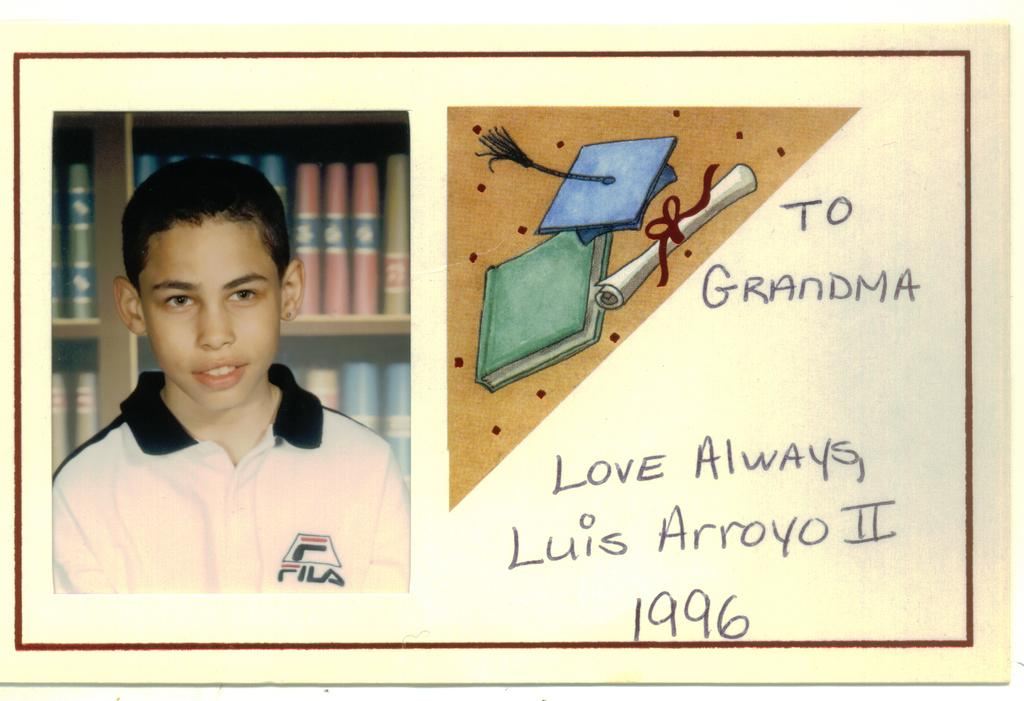What is featured in the image? There is a poster in the image. What can be seen on the poster? The poster contains an image of a kid. How is the kid depicted in the poster? The kid is smiling. What is visible behind the kid in the poster? There are bookshelves behind the kid in the poster. What type of leather material is visible on the kid's shoes in the image? There is no mention of shoes or leather material in the image; the image only features a poster with an image of a kid. 